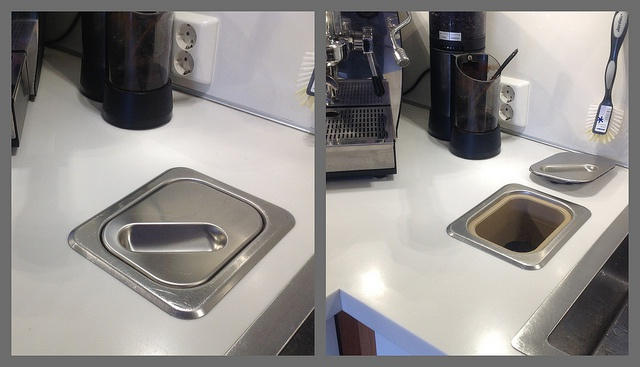Describe the objects in this image and their specific colors. I can see a sink in gray, black, and darkgray tones in this image. 